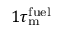Convert formula to latex. <formula><loc_0><loc_0><loc_500><loc_500>1 \tau _ { m } ^ { f u e l }</formula> 